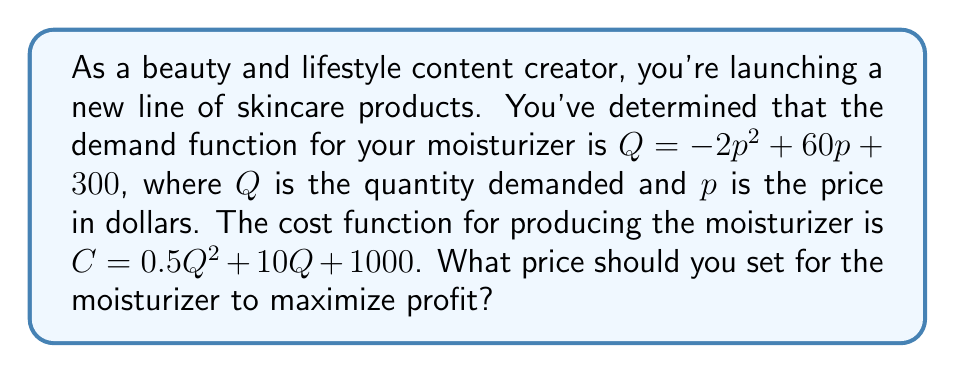Solve this math problem. 1. First, we need to express the profit function in terms of $p$:
   Profit = Revenue - Cost
   $\Pi = pQ - C$

2. Substitute the demand function into the profit equation:
   $\Pi = p(-2p^2 + 60p + 300) - (0.5(-2p^2 + 60p + 300)^2 + 10(-2p^2 + 60p + 300) + 1000)$

3. Expand and simplify the equation:
   $\Pi = -2p^3 + 60p^2 + 300p - 0.5(4p^4 - 240p^3 - 1200p^2 + 3600p + 90000) - 20p^2 + 600p - 3000 - 1000$
   $\Pi = -2p^3 + 60p^2 + 300p - 2p^4 + 120p^3 + 600p^2 - 1800p - 45000 - 20p^2 + 600p - 4000$
   $\Pi = -2p^4 + 118p^3 + 640p^2 - 900p - 49000$

4. To find the maximum profit, we need to find where the derivative of the profit function equals zero:
   $\frac{d\Pi}{dp} = -8p^3 + 354p^2 + 1280p - 900$

5. Set the derivative equal to zero and solve for $p$:
   $-8p^3 + 354p^2 + 1280p - 900 = 0$

6. This cubic equation can be solved using numerical methods or a graphing calculator. The solution that maximizes profit is approximately $p = 22.61$.

7. To verify this is a maximum, we can check the second derivative is negative at this point:
   $\frac{d^2\Pi}{dp^2} = -24p^2 + 708p + 1280$
   At $p = 22.61$, this is negative, confirming a maximum.
Answer: $22.61 